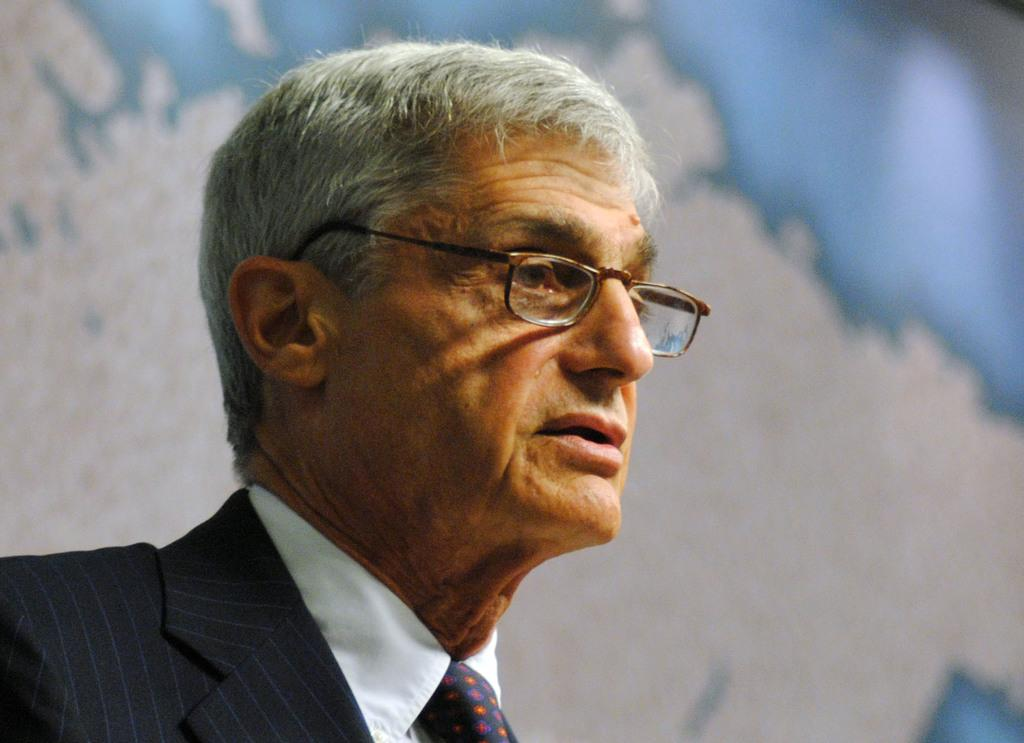What can be seen in the image? There is a person in the image. What is the person wearing on their upper body? The person is wearing a white shirt and a black blazer. What accessory is the person wearing? The person is wearing spectacles. What colors are present in the background of the image? The background of the image is white and blue in color. How is the background of the image depicted? The background is blurry. What type of hair is the person paying attention to in the image? There is no hair visible in the image, and the person is not paying attention to any hair. 